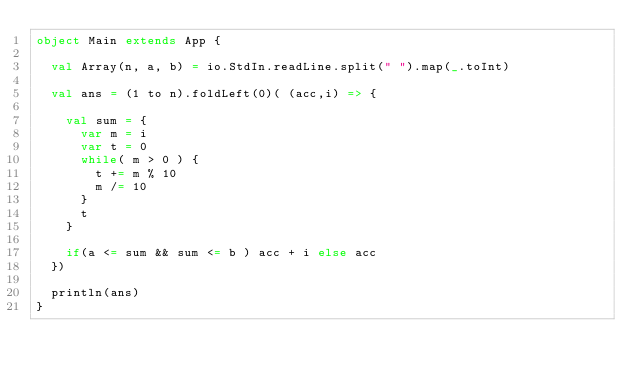<code> <loc_0><loc_0><loc_500><loc_500><_Scala_>object Main extends App {

  val Array(n, a, b) = io.StdIn.readLine.split(" ").map(_.toInt)

  val ans = (1 to n).foldLeft(0)( (acc,i) => {

    val sum = {
      var m = i
      var t = 0
      while( m > 0 ) {
        t += m % 10
        m /= 10
      }
      t
    }

    if(a <= sum && sum <= b ) acc + i else acc
  })

  println(ans)
}</code> 